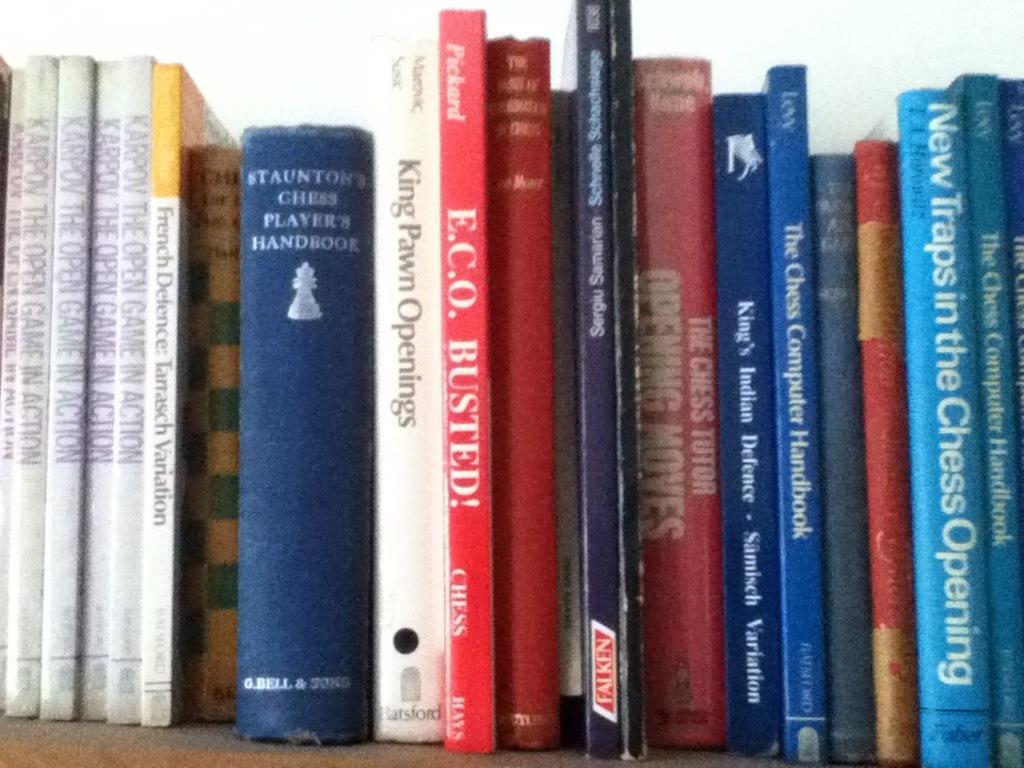How would you summarize this image in a sentence or two? In this image I can see few books on a wooden board. On the books, I can see the text. 